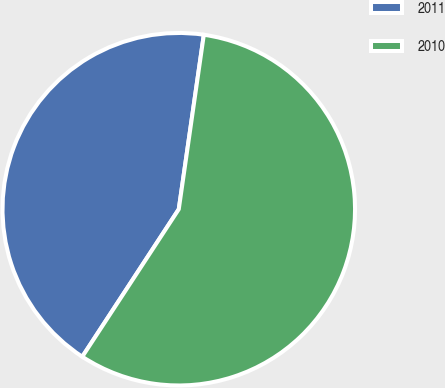Convert chart. <chart><loc_0><loc_0><loc_500><loc_500><pie_chart><fcel>2011<fcel>2010<nl><fcel>43.05%<fcel>56.95%<nl></chart> 